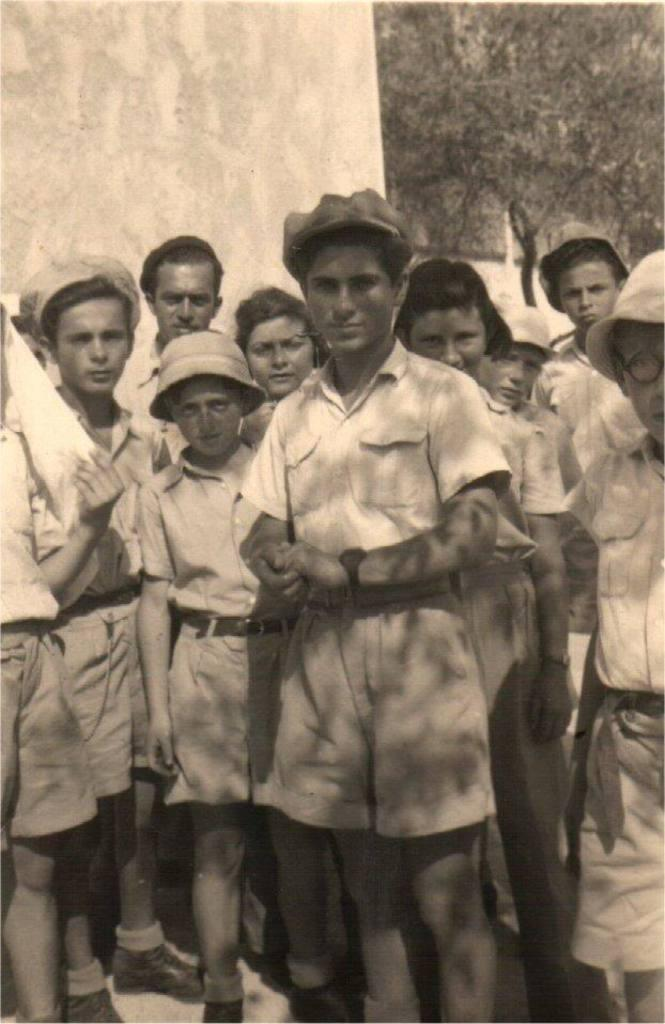What is happening in the middle of the image? There are people standing in the middle of the image. What can be seen in the background of the image? There are trees visible in the background, and there is also a wall. What type of paint is being used by the people in the image? There is no paint or painting activity present in the image; the people are simply standing. 